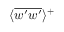<formula> <loc_0><loc_0><loc_500><loc_500>\text  langle \overline{ } { { w ^ { } { \prime } w ^ { } { \prime } } } \text  rangle ^{ } { + }</formula> 